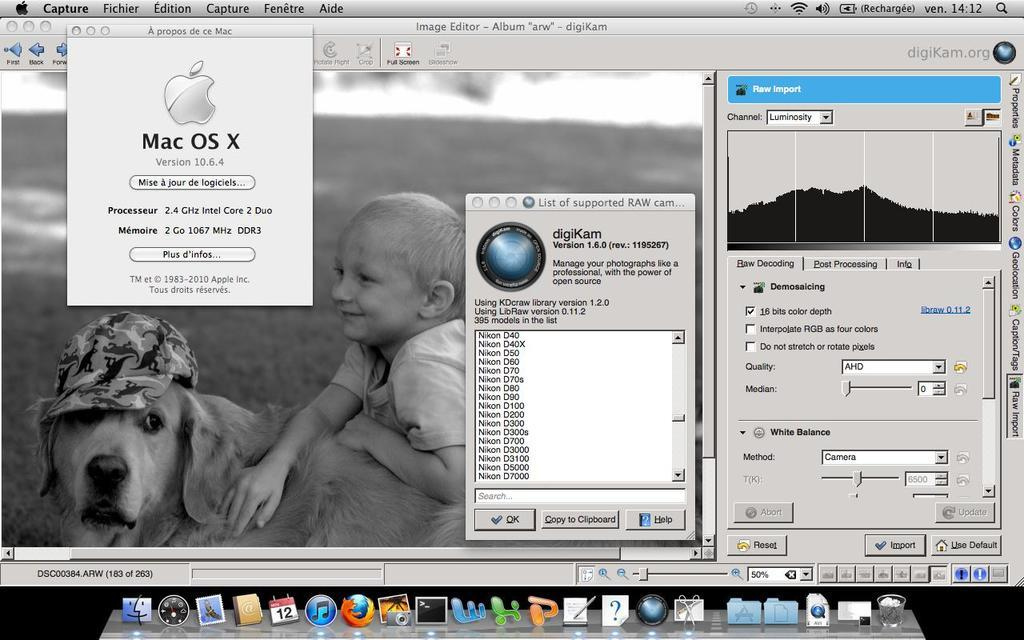What is the main subject of the image? The main subject of the image is a screenshot. What can be seen within the screenshot? There are icons visible in the image. Can you describe the background of the image? There is a person and a dog in the background of the image. Is there any text present in the image? Yes, there is text written on the image. What is the person's interest or crush in the image? There is no information about the person's interest or crush in the image. What things are the dog playing with in the image? There are no things visible in the image that the dog is playing with. 